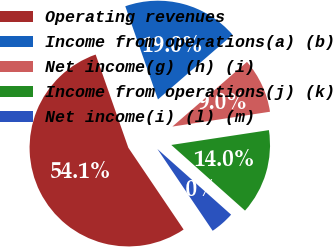<chart> <loc_0><loc_0><loc_500><loc_500><pie_chart><fcel>Operating revenues<fcel>Income from operations(a) (b)<fcel>Net income(g) (h) (i)<fcel>Income from operations(j) (k)<fcel>Net income(i) (l) (m)<nl><fcel>54.09%<fcel>19.0%<fcel>8.97%<fcel>13.98%<fcel>3.96%<nl></chart> 